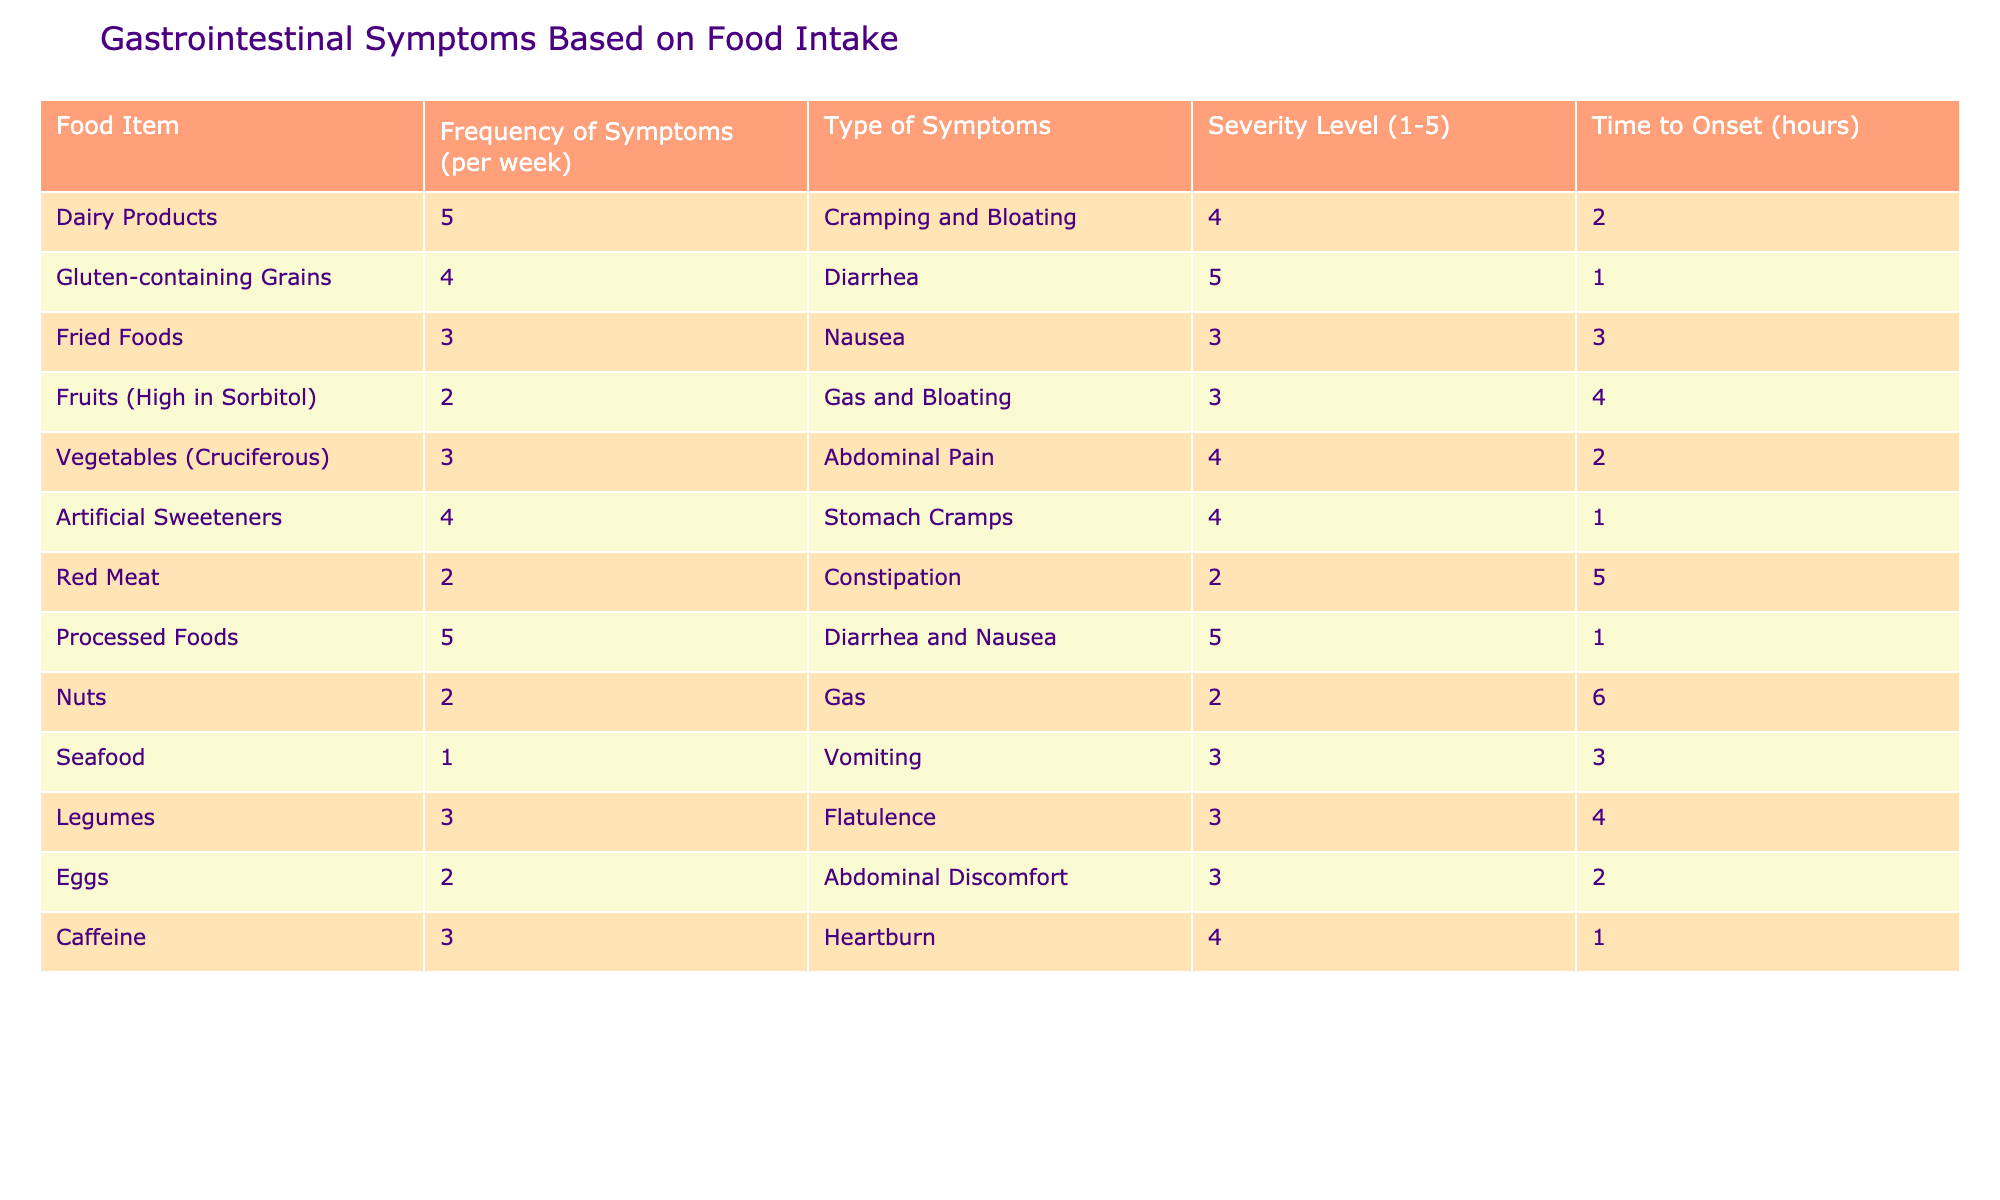What food item has the highest frequency of symptoms? The highest frequency of symptoms is observed in "Dairy Products" and "Processed Foods," both with a frequency of 5 symptoms per week.
Answer: Dairy Products, Processed Foods What is the severity level of gluten-containing grains? The severity level for gluten-containing grains is listed as 5, indicating a high intensity of symptoms.
Answer: 5 Which food items have a time to onset of 1 hour? The food items with a time to onset of 1 hour are "Gluten-containing Grains" and "Artificial Sweeteners."
Answer: Gluten-containing Grains, Artificial Sweeteners What is the total frequency of symptoms for fried foods and red meat combined? The frequency for fried foods is 3, and for red meat, it is 2. Adding them gives a total of 3 + 2 = 5.
Answer: 5 Is there any food with a frequency of symptoms of 1? Yes, "Seafood" has a frequency of 1 symptom per week.
Answer: Yes What food item has the lowest severity level? The food item with the lowest severity level is "Red Meat," with a severity level of 2.
Answer: Red Meat What is the average severity level of all food items? To find the average severity level, sum the severity levels (4 + 5 + 3 + 3 + 4 + 4 + 2 + 5 + 2 + 3 + 3 + 4) which equals 47. There are 12 food items, so the average is 47 / 12 = 3.92.
Answer: 3.92 Which type of symptom is associated with the highest severity level? The symptom "Diarrhea" is associated with the highest severity level of 5, seen in both "Gluten-containing Grains" and "Processed Foods."
Answer: Diarrhea How many food items cause gas or bloating? The food items causing gas or bloating are "Fruits (High in Sorbitol)," "Vegetables (Cruciferous)," "Nuts," and "Artificial Sweeteners," totaling 4 items.
Answer: 4 What is the frequency of symptoms for legumes and vegetables combined? The frequency for legumes is 3, and for vegetables (cruciferous), it is 3. Adding them gives a total of 3 + 3 = 6.
Answer: 6 